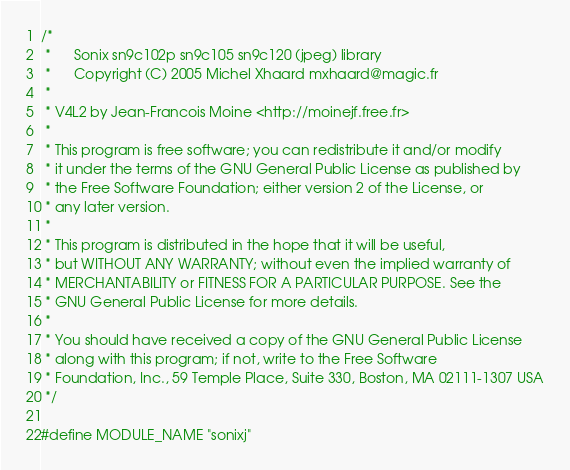Convert code to text. <code><loc_0><loc_0><loc_500><loc_500><_C_>/*
 *		Sonix sn9c102p sn9c105 sn9c120 (jpeg) library
 *		Copyright (C) 2005 Michel Xhaard mxhaard@magic.fr
 *
 * V4L2 by Jean-Francois Moine <http://moinejf.free.fr>
 *
 * This program is free software; you can redistribute it and/or modify
 * it under the terms of the GNU General Public License as published by
 * the Free Software Foundation; either version 2 of the License, or
 * any later version.
 *
 * This program is distributed in the hope that it will be useful,
 * but WITHOUT ANY WARRANTY; without even the implied warranty of
 * MERCHANTABILITY or FITNESS FOR A PARTICULAR PURPOSE. See the
 * GNU General Public License for more details.
 *
 * You should have received a copy of the GNU General Public License
 * along with this program; if not, write to the Free Software
 * Foundation, Inc., 59 Temple Place, Suite 330, Boston, MA 02111-1307 USA
 */

#define MODULE_NAME "sonixj"
</code> 